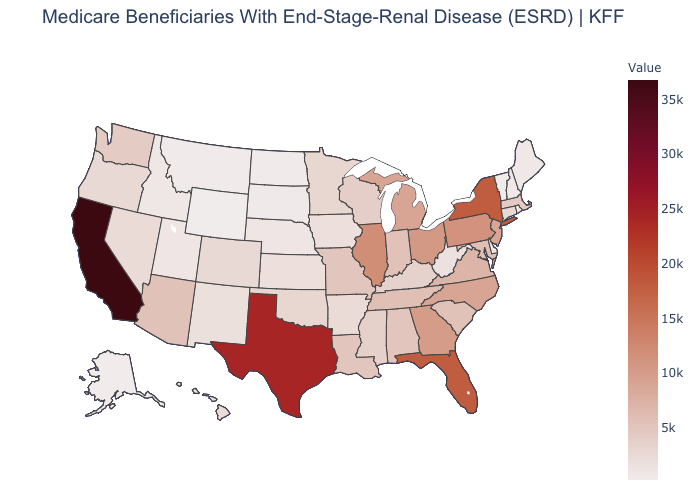Which states hav the highest value in the West?
Short answer required. California. Does Vermont have the lowest value in the Northeast?
Keep it brief. Yes. Which states have the highest value in the USA?
Keep it brief. California. Among the states that border Michigan , which have the highest value?
Be succinct. Ohio. Which states have the lowest value in the USA?
Give a very brief answer. Wyoming. Which states hav the highest value in the West?
Concise answer only. California. Which states hav the highest value in the West?
Be succinct. California. Is the legend a continuous bar?
Keep it brief. Yes. 